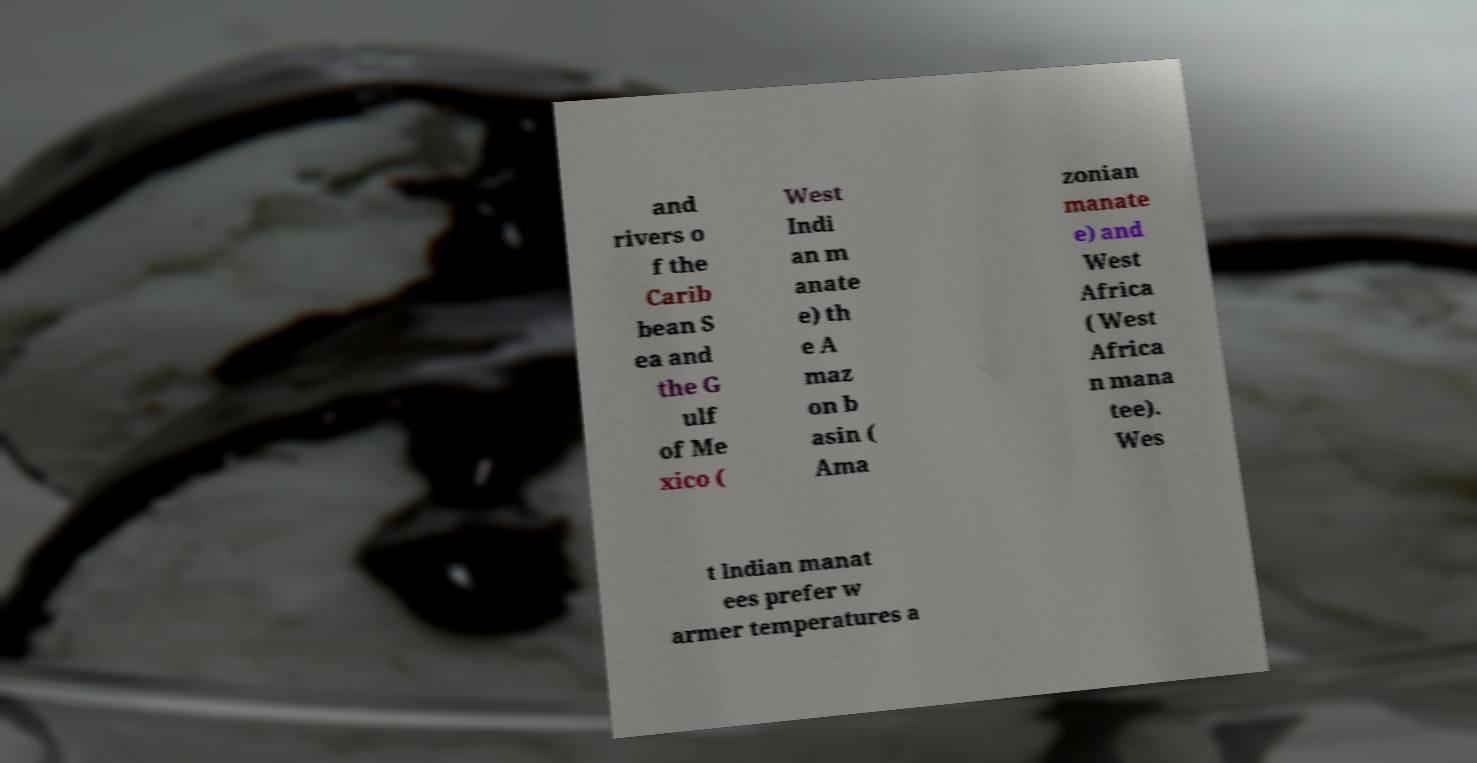I need the written content from this picture converted into text. Can you do that? and rivers o f the Carib bean S ea and the G ulf of Me xico ( West Indi an m anate e) th e A maz on b asin ( Ama zonian manate e) and West Africa ( West Africa n mana tee). Wes t Indian manat ees prefer w armer temperatures a 